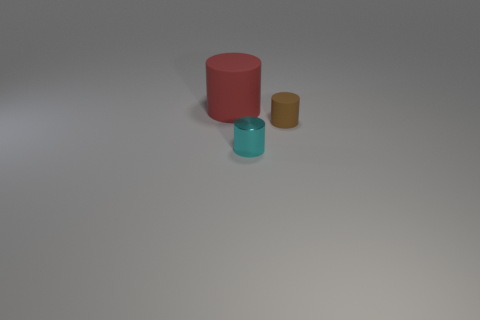There is a object that is on the right side of the tiny thing that is in front of the brown matte thing; are there any cyan things in front of it?
Give a very brief answer. Yes. What is the shape of the other object that is the same size as the cyan metallic object?
Provide a succinct answer. Cylinder. What color is the tiny rubber object that is the same shape as the cyan shiny object?
Provide a succinct answer. Brown. What number of objects are small cyan things or brown cylinders?
Your answer should be very brief. 2. There is a tiny thing left of the brown rubber thing; is its shape the same as the matte object on the left side of the tiny rubber object?
Your answer should be compact. Yes. What is the shape of the small object behind the tiny metallic thing?
Your answer should be compact. Cylinder. Are there the same number of tiny cyan cylinders behind the brown thing and tiny cyan things on the left side of the red cylinder?
Provide a short and direct response. Yes. How many things are shiny cylinders or objects that are behind the small brown cylinder?
Your response must be concise. 2. There is a object that is right of the red thing and to the left of the brown rubber cylinder; what is its shape?
Keep it short and to the point. Cylinder. There is a small cylinder in front of the small thing right of the cyan cylinder; what is its material?
Give a very brief answer. Metal. 